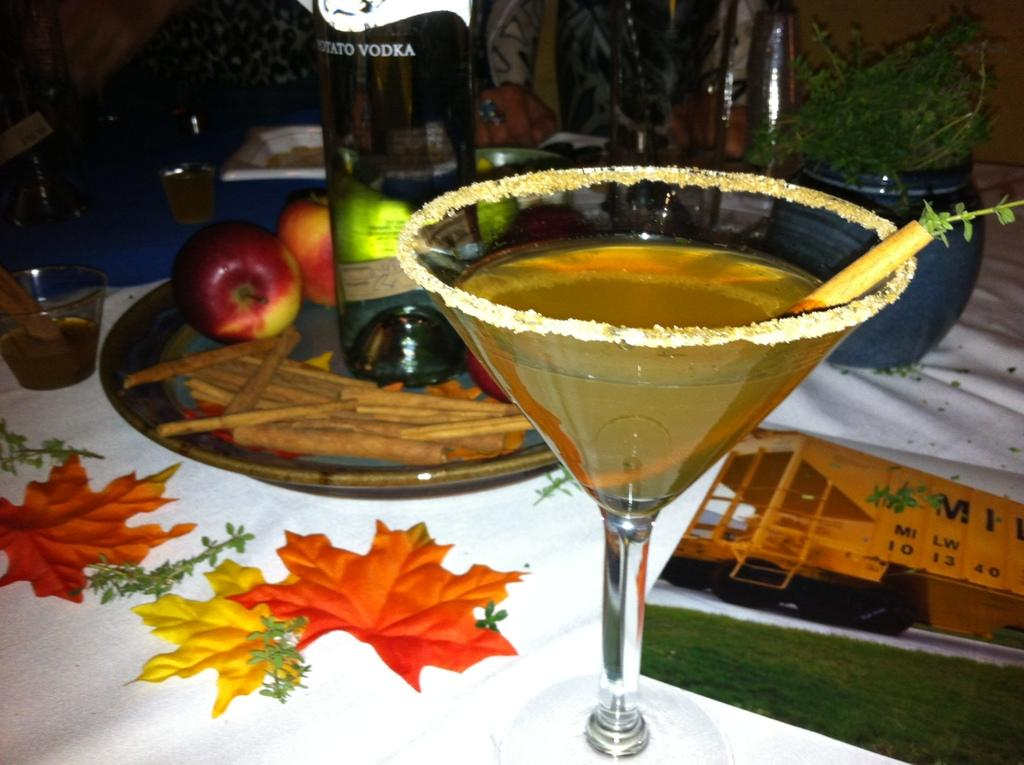What is the main object in the center of the image? There is a table in the center of the image. What is covering the table? There is a cloth on the table. What type of beverage is present on the table? There is a wine bottle on the table. What is used for drinking the beverage? There is a wine glass on the table. What type of dishware is present on the table? There are bowls and plates on the table. What type of fruit is present on the table? There are apples on the table. What type of utensil is present on the table? There are sticks on the table. What other objects are present on the table? There are other objects on the table. What type of peace treaty is being signed on the table in the image? There is no indication of a peace treaty or any signing activity in the image. 